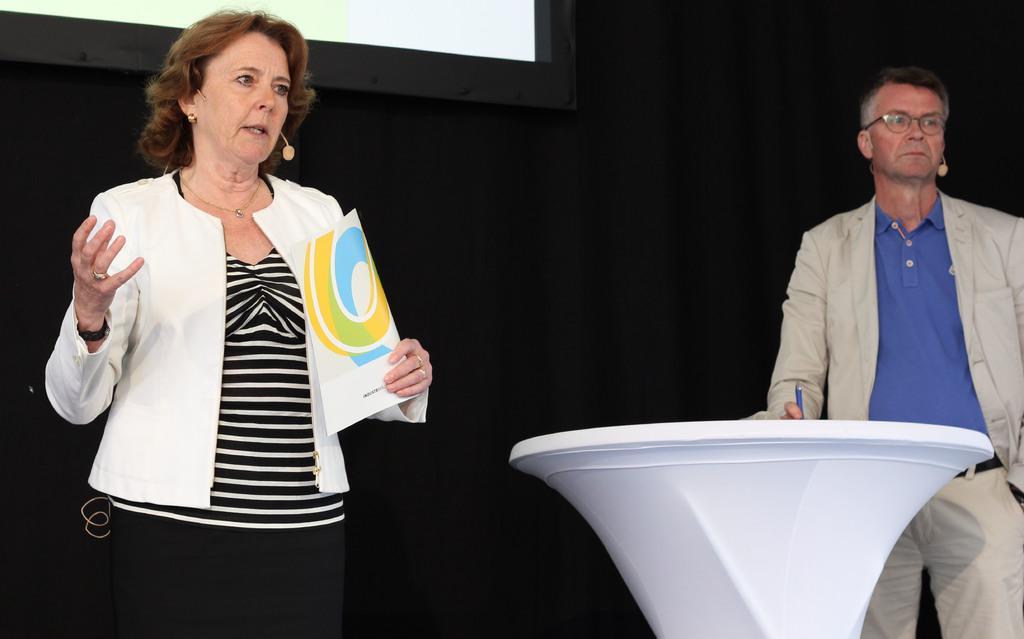Please provide a concise description of this image. In the left I can see a woman is standing and holding a brochure in hand. On the right I can see a man is standing and holding a pen in hand and a table. In the background I can see curtain and a screen. This image is taken on the stage in a hall. 